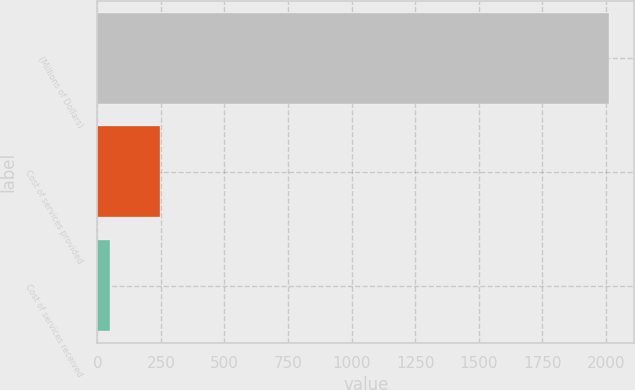<chart> <loc_0><loc_0><loc_500><loc_500><bar_chart><fcel>(Millions of Dollars)<fcel>Cost of services provided<fcel>Cost of services received<nl><fcel>2012<fcel>245.3<fcel>49<nl></chart> 